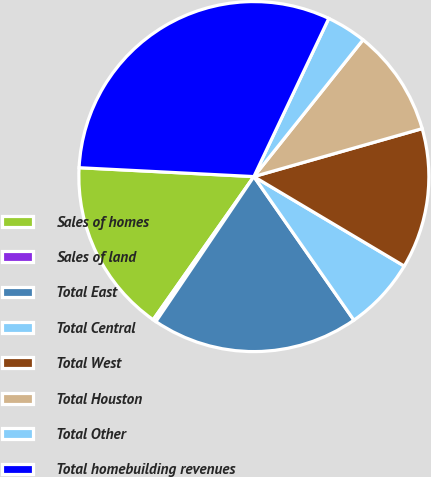Convert chart. <chart><loc_0><loc_0><loc_500><loc_500><pie_chart><fcel>Sales of homes<fcel>Sales of land<fcel>Total East<fcel>Total Central<fcel>Total West<fcel>Total Houston<fcel>Total Other<fcel>Total homebuilding revenues<nl><fcel>16.05%<fcel>0.3%<fcel>19.14%<fcel>6.77%<fcel>12.96%<fcel>9.86%<fcel>3.68%<fcel>31.23%<nl></chart> 